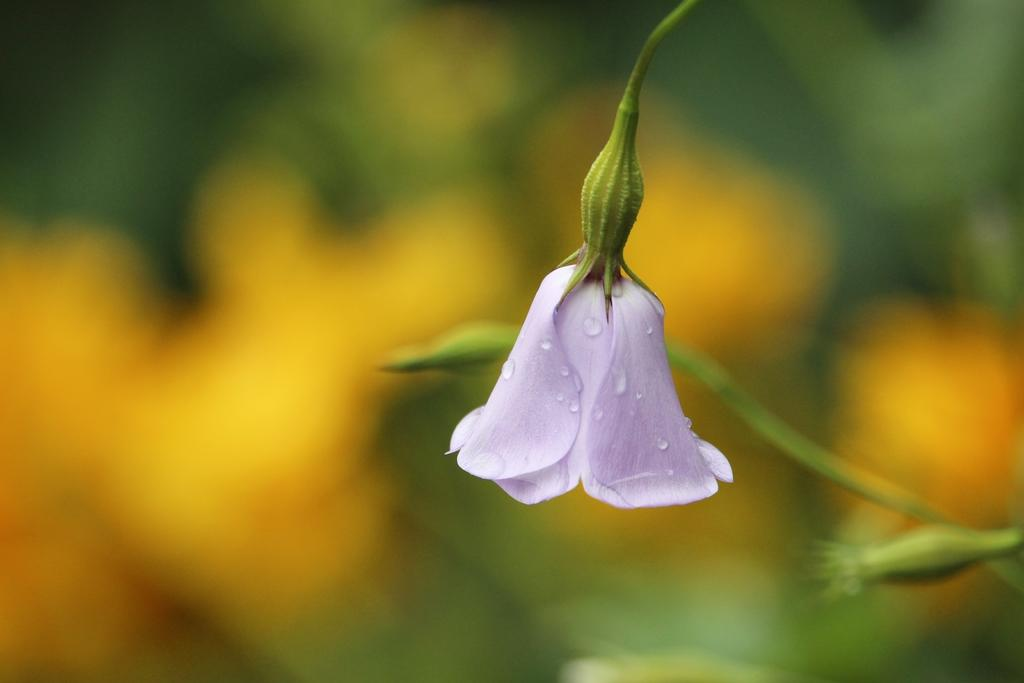What is the main subject of the image? There is a flower in the image. What part of the flower is visible in the image? There is a stem in the image. Can you describe the background of the image? The background of the image is blurred. What type of punishment is being given to the flower in the image? There is no punishment being given to the flower in the image; it is a still image of a flower with a stem. Is there a crook present in the image? There is no crook present in the image; it features a flower and a stem. 